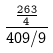Convert formula to latex. <formula><loc_0><loc_0><loc_500><loc_500>\frac { \frac { 2 6 3 } { 4 } } { 4 0 9 / 9 }</formula> 